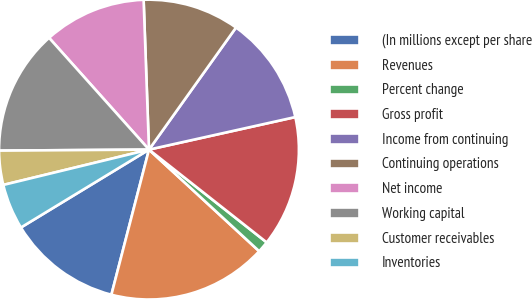<chart> <loc_0><loc_0><loc_500><loc_500><pie_chart><fcel>(In millions except per share<fcel>Revenues<fcel>Percent change<fcel>Gross profit<fcel>Income from continuing<fcel>Continuing operations<fcel>Net income<fcel>Working capital<fcel>Customer receivables<fcel>Inventories<nl><fcel>12.27%<fcel>17.18%<fcel>1.23%<fcel>14.11%<fcel>11.66%<fcel>10.43%<fcel>11.04%<fcel>13.5%<fcel>3.68%<fcel>4.91%<nl></chart> 